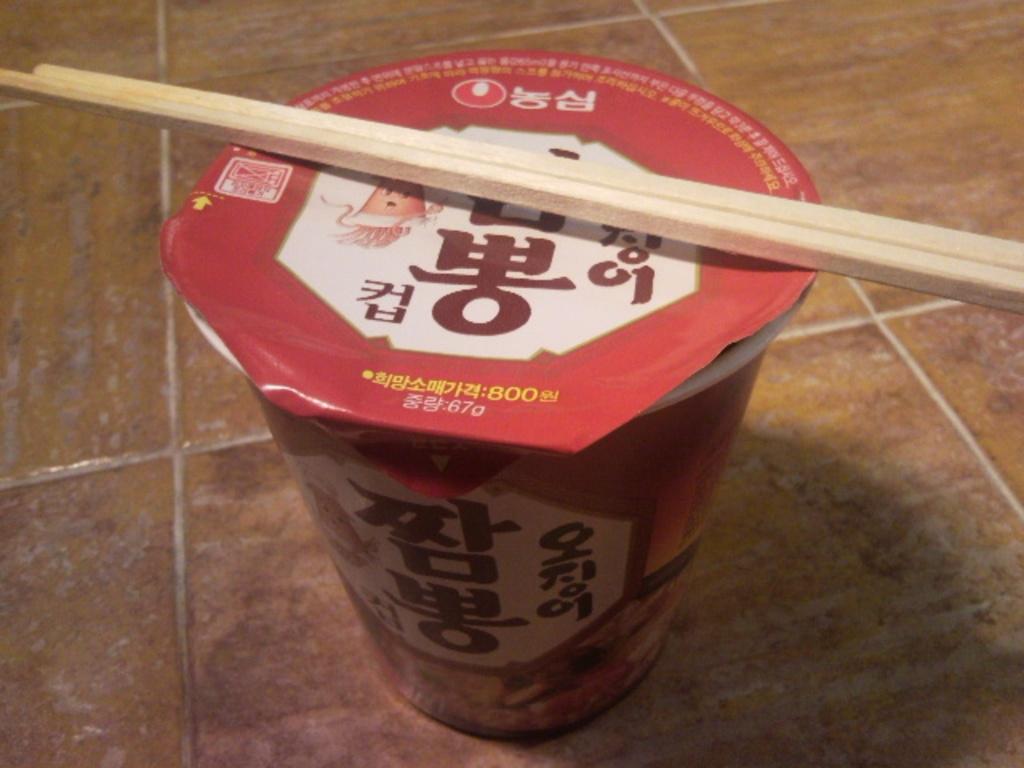Describe this image in one or two sentences. This image consist of Glass with cap and two sticks. This looks like instant noodles and those are called chopsticks. The box is in red color and something is written written in Chinese language. 